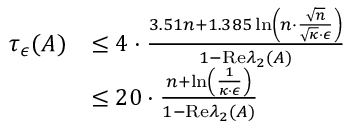Convert formula to latex. <formula><loc_0><loc_0><loc_500><loc_500>\begin{array} { r l } { \tau _ { \epsilon } ( A ) } & { \leq 4 \cdot \frac { 3 . 5 1 n + 1 . 3 8 5 \ln \left ( n \cdot \frac { \sqrt { n } } { \sqrt { \kappa } \cdot \epsilon } \right ) } { 1 - R e \lambda _ { 2 } ( A ) } } \\ & { \leq 2 0 \cdot \frac { n + \ln \left ( \frac { 1 } { \kappa \cdot \epsilon } \right ) } { 1 - R e \lambda _ { 2 } ( A ) } } \end{array}</formula> 